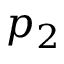Convert formula to latex. <formula><loc_0><loc_0><loc_500><loc_500>p _ { 2 }</formula> 